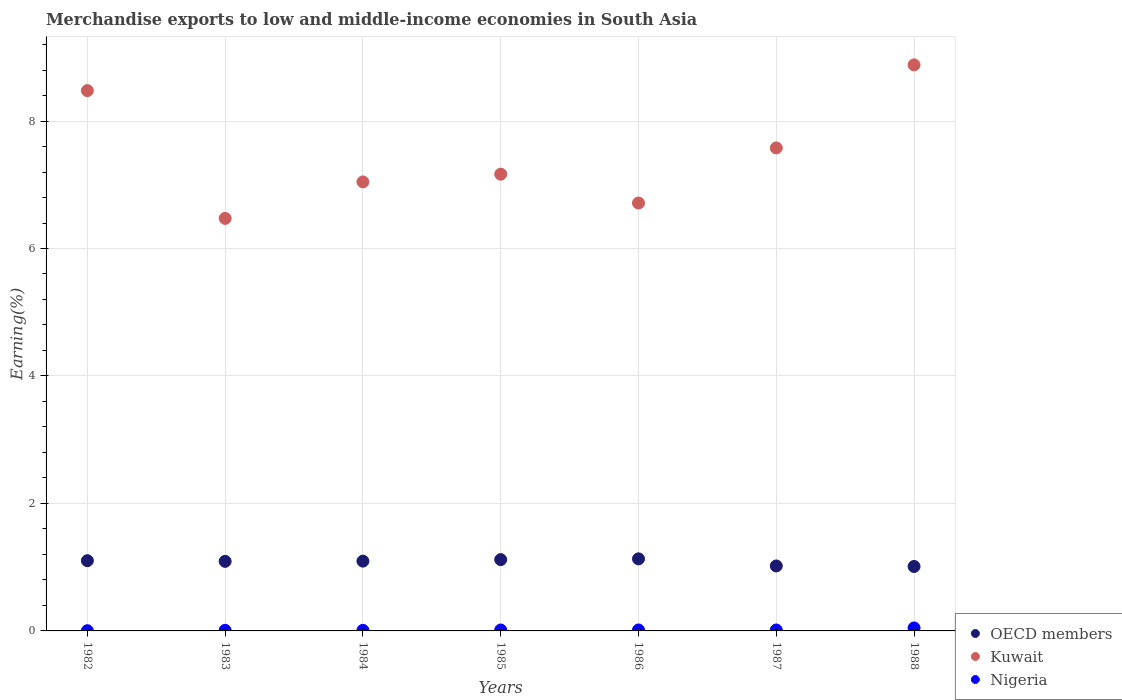How many different coloured dotlines are there?
Ensure brevity in your answer.  3. Is the number of dotlines equal to the number of legend labels?
Offer a terse response. Yes. What is the percentage of amount earned from merchandise exports in OECD members in 1986?
Provide a short and direct response. 1.13. Across all years, what is the maximum percentage of amount earned from merchandise exports in Nigeria?
Your answer should be compact. 0.05. Across all years, what is the minimum percentage of amount earned from merchandise exports in Kuwait?
Ensure brevity in your answer.  6.47. In which year was the percentage of amount earned from merchandise exports in OECD members maximum?
Offer a terse response. 1986. In which year was the percentage of amount earned from merchandise exports in Kuwait minimum?
Provide a short and direct response. 1983. What is the total percentage of amount earned from merchandise exports in OECD members in the graph?
Offer a very short reply. 7.57. What is the difference between the percentage of amount earned from merchandise exports in Kuwait in 1986 and that in 1988?
Give a very brief answer. -2.17. What is the difference between the percentage of amount earned from merchandise exports in OECD members in 1983 and the percentage of amount earned from merchandise exports in Kuwait in 1987?
Ensure brevity in your answer.  -6.49. What is the average percentage of amount earned from merchandise exports in Kuwait per year?
Ensure brevity in your answer.  7.48. In the year 1986, what is the difference between the percentage of amount earned from merchandise exports in OECD members and percentage of amount earned from merchandise exports in Nigeria?
Offer a very short reply. 1.12. What is the ratio of the percentage of amount earned from merchandise exports in OECD members in 1985 to that in 1986?
Make the answer very short. 0.99. Is the difference between the percentage of amount earned from merchandise exports in OECD members in 1983 and 1985 greater than the difference between the percentage of amount earned from merchandise exports in Nigeria in 1983 and 1985?
Give a very brief answer. No. What is the difference between the highest and the second highest percentage of amount earned from merchandise exports in Kuwait?
Offer a terse response. 0.4. What is the difference between the highest and the lowest percentage of amount earned from merchandise exports in Kuwait?
Make the answer very short. 2.41. In how many years, is the percentage of amount earned from merchandise exports in OECD members greater than the average percentage of amount earned from merchandise exports in OECD members taken over all years?
Give a very brief answer. 5. Is it the case that in every year, the sum of the percentage of amount earned from merchandise exports in Kuwait and percentage of amount earned from merchandise exports in Nigeria  is greater than the percentage of amount earned from merchandise exports in OECD members?
Give a very brief answer. Yes. Is the percentage of amount earned from merchandise exports in OECD members strictly less than the percentage of amount earned from merchandise exports in Nigeria over the years?
Make the answer very short. No. Does the graph contain any zero values?
Provide a succinct answer. No. Does the graph contain grids?
Your response must be concise. Yes. Where does the legend appear in the graph?
Offer a very short reply. Bottom right. What is the title of the graph?
Provide a succinct answer. Merchandise exports to low and middle-income economies in South Asia. What is the label or title of the Y-axis?
Offer a terse response. Earning(%). What is the Earning(%) of OECD members in 1982?
Your response must be concise. 1.1. What is the Earning(%) in Kuwait in 1982?
Your answer should be compact. 8.48. What is the Earning(%) of Nigeria in 1982?
Your answer should be very brief. 0. What is the Earning(%) of OECD members in 1983?
Your answer should be very brief. 1.09. What is the Earning(%) of Kuwait in 1983?
Offer a terse response. 6.47. What is the Earning(%) of Nigeria in 1983?
Give a very brief answer. 0.01. What is the Earning(%) of OECD members in 1984?
Your response must be concise. 1.1. What is the Earning(%) of Kuwait in 1984?
Your answer should be very brief. 7.04. What is the Earning(%) in Nigeria in 1984?
Provide a succinct answer. 0.01. What is the Earning(%) of OECD members in 1985?
Keep it short and to the point. 1.12. What is the Earning(%) in Kuwait in 1985?
Your answer should be very brief. 7.17. What is the Earning(%) of Nigeria in 1985?
Your answer should be compact. 0.01. What is the Earning(%) of OECD members in 1986?
Offer a very short reply. 1.13. What is the Earning(%) of Kuwait in 1986?
Ensure brevity in your answer.  6.71. What is the Earning(%) in Nigeria in 1986?
Your answer should be compact. 0.02. What is the Earning(%) of OECD members in 1987?
Your answer should be compact. 1.02. What is the Earning(%) in Kuwait in 1987?
Your answer should be compact. 7.58. What is the Earning(%) in Nigeria in 1987?
Offer a very short reply. 0.02. What is the Earning(%) in OECD members in 1988?
Make the answer very short. 1.01. What is the Earning(%) in Kuwait in 1988?
Give a very brief answer. 8.88. What is the Earning(%) in Nigeria in 1988?
Keep it short and to the point. 0.05. Across all years, what is the maximum Earning(%) in OECD members?
Give a very brief answer. 1.13. Across all years, what is the maximum Earning(%) of Kuwait?
Offer a very short reply. 8.88. Across all years, what is the maximum Earning(%) in Nigeria?
Keep it short and to the point. 0.05. Across all years, what is the minimum Earning(%) of OECD members?
Keep it short and to the point. 1.01. Across all years, what is the minimum Earning(%) in Kuwait?
Your answer should be very brief. 6.47. Across all years, what is the minimum Earning(%) in Nigeria?
Provide a short and direct response. 0. What is the total Earning(%) in OECD members in the graph?
Provide a succinct answer. 7.57. What is the total Earning(%) in Kuwait in the graph?
Offer a terse response. 52.33. What is the total Earning(%) of Nigeria in the graph?
Provide a short and direct response. 0.11. What is the difference between the Earning(%) in OECD members in 1982 and that in 1983?
Provide a short and direct response. 0.01. What is the difference between the Earning(%) of Kuwait in 1982 and that in 1983?
Your answer should be very brief. 2. What is the difference between the Earning(%) of Nigeria in 1982 and that in 1983?
Offer a terse response. -0.01. What is the difference between the Earning(%) of OECD members in 1982 and that in 1984?
Give a very brief answer. 0.01. What is the difference between the Earning(%) of Kuwait in 1982 and that in 1984?
Make the answer very short. 1.43. What is the difference between the Earning(%) of Nigeria in 1982 and that in 1984?
Your response must be concise. -0.01. What is the difference between the Earning(%) of OECD members in 1982 and that in 1985?
Ensure brevity in your answer.  -0.02. What is the difference between the Earning(%) of Kuwait in 1982 and that in 1985?
Ensure brevity in your answer.  1.31. What is the difference between the Earning(%) in Nigeria in 1982 and that in 1985?
Provide a short and direct response. -0.01. What is the difference between the Earning(%) of OECD members in 1982 and that in 1986?
Give a very brief answer. -0.03. What is the difference between the Earning(%) in Kuwait in 1982 and that in 1986?
Your answer should be very brief. 1.76. What is the difference between the Earning(%) of Nigeria in 1982 and that in 1986?
Ensure brevity in your answer.  -0.01. What is the difference between the Earning(%) in OECD members in 1982 and that in 1987?
Offer a terse response. 0.08. What is the difference between the Earning(%) in Kuwait in 1982 and that in 1987?
Keep it short and to the point. 0.9. What is the difference between the Earning(%) in Nigeria in 1982 and that in 1987?
Provide a short and direct response. -0.01. What is the difference between the Earning(%) in OECD members in 1982 and that in 1988?
Offer a terse response. 0.09. What is the difference between the Earning(%) of Kuwait in 1982 and that in 1988?
Your answer should be compact. -0.4. What is the difference between the Earning(%) of Nigeria in 1982 and that in 1988?
Offer a very short reply. -0.04. What is the difference between the Earning(%) in OECD members in 1983 and that in 1984?
Keep it short and to the point. -0. What is the difference between the Earning(%) of Kuwait in 1983 and that in 1984?
Give a very brief answer. -0.57. What is the difference between the Earning(%) in OECD members in 1983 and that in 1985?
Keep it short and to the point. -0.03. What is the difference between the Earning(%) in Kuwait in 1983 and that in 1985?
Ensure brevity in your answer.  -0.69. What is the difference between the Earning(%) in Nigeria in 1983 and that in 1985?
Keep it short and to the point. -0.01. What is the difference between the Earning(%) in OECD members in 1983 and that in 1986?
Ensure brevity in your answer.  -0.04. What is the difference between the Earning(%) of Kuwait in 1983 and that in 1986?
Your answer should be compact. -0.24. What is the difference between the Earning(%) of Nigeria in 1983 and that in 1986?
Your answer should be very brief. -0.01. What is the difference between the Earning(%) in OECD members in 1983 and that in 1987?
Provide a succinct answer. 0.07. What is the difference between the Earning(%) in Kuwait in 1983 and that in 1987?
Offer a very short reply. -1.11. What is the difference between the Earning(%) of Nigeria in 1983 and that in 1987?
Make the answer very short. -0.01. What is the difference between the Earning(%) in OECD members in 1983 and that in 1988?
Ensure brevity in your answer.  0.08. What is the difference between the Earning(%) in Kuwait in 1983 and that in 1988?
Your response must be concise. -2.41. What is the difference between the Earning(%) in Nigeria in 1983 and that in 1988?
Give a very brief answer. -0.04. What is the difference between the Earning(%) of OECD members in 1984 and that in 1985?
Give a very brief answer. -0.02. What is the difference between the Earning(%) in Kuwait in 1984 and that in 1985?
Make the answer very short. -0.12. What is the difference between the Earning(%) in Nigeria in 1984 and that in 1985?
Give a very brief answer. -0.01. What is the difference between the Earning(%) in OECD members in 1984 and that in 1986?
Provide a short and direct response. -0.04. What is the difference between the Earning(%) in Kuwait in 1984 and that in 1986?
Ensure brevity in your answer.  0.33. What is the difference between the Earning(%) of Nigeria in 1984 and that in 1986?
Provide a short and direct response. -0.01. What is the difference between the Earning(%) of OECD members in 1984 and that in 1987?
Keep it short and to the point. 0.08. What is the difference between the Earning(%) in Kuwait in 1984 and that in 1987?
Your response must be concise. -0.53. What is the difference between the Earning(%) of Nigeria in 1984 and that in 1987?
Your response must be concise. -0.01. What is the difference between the Earning(%) in OECD members in 1984 and that in 1988?
Offer a very short reply. 0.08. What is the difference between the Earning(%) in Kuwait in 1984 and that in 1988?
Your response must be concise. -1.84. What is the difference between the Earning(%) in Nigeria in 1984 and that in 1988?
Offer a very short reply. -0.04. What is the difference between the Earning(%) of OECD members in 1985 and that in 1986?
Your response must be concise. -0.01. What is the difference between the Earning(%) in Kuwait in 1985 and that in 1986?
Give a very brief answer. 0.45. What is the difference between the Earning(%) of Nigeria in 1985 and that in 1986?
Give a very brief answer. -0. What is the difference between the Earning(%) in OECD members in 1985 and that in 1987?
Your answer should be compact. 0.1. What is the difference between the Earning(%) of Kuwait in 1985 and that in 1987?
Your answer should be compact. -0.41. What is the difference between the Earning(%) in Nigeria in 1985 and that in 1987?
Your answer should be compact. -0. What is the difference between the Earning(%) in OECD members in 1985 and that in 1988?
Provide a succinct answer. 0.11. What is the difference between the Earning(%) of Kuwait in 1985 and that in 1988?
Your answer should be compact. -1.71. What is the difference between the Earning(%) of Nigeria in 1985 and that in 1988?
Provide a succinct answer. -0.03. What is the difference between the Earning(%) of OECD members in 1986 and that in 1987?
Your answer should be very brief. 0.11. What is the difference between the Earning(%) in Kuwait in 1986 and that in 1987?
Ensure brevity in your answer.  -0.87. What is the difference between the Earning(%) in Nigeria in 1986 and that in 1987?
Give a very brief answer. -0. What is the difference between the Earning(%) of OECD members in 1986 and that in 1988?
Provide a short and direct response. 0.12. What is the difference between the Earning(%) in Kuwait in 1986 and that in 1988?
Your response must be concise. -2.17. What is the difference between the Earning(%) of Nigeria in 1986 and that in 1988?
Your answer should be very brief. -0.03. What is the difference between the Earning(%) in OECD members in 1987 and that in 1988?
Offer a very short reply. 0.01. What is the difference between the Earning(%) in Kuwait in 1987 and that in 1988?
Offer a very short reply. -1.3. What is the difference between the Earning(%) in Nigeria in 1987 and that in 1988?
Offer a terse response. -0.03. What is the difference between the Earning(%) of OECD members in 1982 and the Earning(%) of Kuwait in 1983?
Provide a succinct answer. -5.37. What is the difference between the Earning(%) of OECD members in 1982 and the Earning(%) of Nigeria in 1983?
Make the answer very short. 1.09. What is the difference between the Earning(%) in Kuwait in 1982 and the Earning(%) in Nigeria in 1983?
Offer a very short reply. 8.47. What is the difference between the Earning(%) in OECD members in 1982 and the Earning(%) in Kuwait in 1984?
Offer a terse response. -5.94. What is the difference between the Earning(%) in OECD members in 1982 and the Earning(%) in Nigeria in 1984?
Ensure brevity in your answer.  1.09. What is the difference between the Earning(%) in Kuwait in 1982 and the Earning(%) in Nigeria in 1984?
Your response must be concise. 8.47. What is the difference between the Earning(%) in OECD members in 1982 and the Earning(%) in Kuwait in 1985?
Give a very brief answer. -6.06. What is the difference between the Earning(%) in OECD members in 1982 and the Earning(%) in Nigeria in 1985?
Your answer should be very brief. 1.09. What is the difference between the Earning(%) in Kuwait in 1982 and the Earning(%) in Nigeria in 1985?
Ensure brevity in your answer.  8.46. What is the difference between the Earning(%) in OECD members in 1982 and the Earning(%) in Kuwait in 1986?
Offer a terse response. -5.61. What is the difference between the Earning(%) of OECD members in 1982 and the Earning(%) of Nigeria in 1986?
Make the answer very short. 1.09. What is the difference between the Earning(%) in Kuwait in 1982 and the Earning(%) in Nigeria in 1986?
Ensure brevity in your answer.  8.46. What is the difference between the Earning(%) in OECD members in 1982 and the Earning(%) in Kuwait in 1987?
Your answer should be very brief. -6.48. What is the difference between the Earning(%) of OECD members in 1982 and the Earning(%) of Nigeria in 1987?
Your answer should be compact. 1.09. What is the difference between the Earning(%) of Kuwait in 1982 and the Earning(%) of Nigeria in 1987?
Ensure brevity in your answer.  8.46. What is the difference between the Earning(%) in OECD members in 1982 and the Earning(%) in Kuwait in 1988?
Your answer should be very brief. -7.78. What is the difference between the Earning(%) of OECD members in 1982 and the Earning(%) of Nigeria in 1988?
Make the answer very short. 1.06. What is the difference between the Earning(%) of Kuwait in 1982 and the Earning(%) of Nigeria in 1988?
Offer a terse response. 8.43. What is the difference between the Earning(%) in OECD members in 1983 and the Earning(%) in Kuwait in 1984?
Your answer should be very brief. -5.95. What is the difference between the Earning(%) of OECD members in 1983 and the Earning(%) of Nigeria in 1984?
Give a very brief answer. 1.08. What is the difference between the Earning(%) in Kuwait in 1983 and the Earning(%) in Nigeria in 1984?
Provide a short and direct response. 6.46. What is the difference between the Earning(%) of OECD members in 1983 and the Earning(%) of Kuwait in 1985?
Offer a terse response. -6.07. What is the difference between the Earning(%) in Kuwait in 1983 and the Earning(%) in Nigeria in 1985?
Offer a very short reply. 6.46. What is the difference between the Earning(%) in OECD members in 1983 and the Earning(%) in Kuwait in 1986?
Offer a very short reply. -5.62. What is the difference between the Earning(%) of OECD members in 1983 and the Earning(%) of Nigeria in 1986?
Provide a short and direct response. 1.08. What is the difference between the Earning(%) of Kuwait in 1983 and the Earning(%) of Nigeria in 1986?
Make the answer very short. 6.46. What is the difference between the Earning(%) of OECD members in 1983 and the Earning(%) of Kuwait in 1987?
Your answer should be compact. -6.49. What is the difference between the Earning(%) in OECD members in 1983 and the Earning(%) in Nigeria in 1987?
Keep it short and to the point. 1.08. What is the difference between the Earning(%) of Kuwait in 1983 and the Earning(%) of Nigeria in 1987?
Provide a short and direct response. 6.46. What is the difference between the Earning(%) of OECD members in 1983 and the Earning(%) of Kuwait in 1988?
Your answer should be compact. -7.79. What is the difference between the Earning(%) in OECD members in 1983 and the Earning(%) in Nigeria in 1988?
Provide a short and direct response. 1.04. What is the difference between the Earning(%) of Kuwait in 1983 and the Earning(%) of Nigeria in 1988?
Provide a succinct answer. 6.43. What is the difference between the Earning(%) of OECD members in 1984 and the Earning(%) of Kuwait in 1985?
Your answer should be compact. -6.07. What is the difference between the Earning(%) in OECD members in 1984 and the Earning(%) in Nigeria in 1985?
Your response must be concise. 1.08. What is the difference between the Earning(%) of Kuwait in 1984 and the Earning(%) of Nigeria in 1985?
Ensure brevity in your answer.  7.03. What is the difference between the Earning(%) in OECD members in 1984 and the Earning(%) in Kuwait in 1986?
Your response must be concise. -5.62. What is the difference between the Earning(%) of OECD members in 1984 and the Earning(%) of Nigeria in 1986?
Keep it short and to the point. 1.08. What is the difference between the Earning(%) of Kuwait in 1984 and the Earning(%) of Nigeria in 1986?
Your answer should be compact. 7.03. What is the difference between the Earning(%) in OECD members in 1984 and the Earning(%) in Kuwait in 1987?
Keep it short and to the point. -6.48. What is the difference between the Earning(%) in OECD members in 1984 and the Earning(%) in Nigeria in 1987?
Your answer should be compact. 1.08. What is the difference between the Earning(%) in Kuwait in 1984 and the Earning(%) in Nigeria in 1987?
Offer a very short reply. 7.03. What is the difference between the Earning(%) in OECD members in 1984 and the Earning(%) in Kuwait in 1988?
Make the answer very short. -7.79. What is the difference between the Earning(%) of OECD members in 1984 and the Earning(%) of Nigeria in 1988?
Offer a very short reply. 1.05. What is the difference between the Earning(%) of Kuwait in 1984 and the Earning(%) of Nigeria in 1988?
Provide a succinct answer. 7. What is the difference between the Earning(%) in OECD members in 1985 and the Earning(%) in Kuwait in 1986?
Offer a terse response. -5.59. What is the difference between the Earning(%) in OECD members in 1985 and the Earning(%) in Nigeria in 1986?
Give a very brief answer. 1.1. What is the difference between the Earning(%) of Kuwait in 1985 and the Earning(%) of Nigeria in 1986?
Offer a terse response. 7.15. What is the difference between the Earning(%) in OECD members in 1985 and the Earning(%) in Kuwait in 1987?
Your response must be concise. -6.46. What is the difference between the Earning(%) in OECD members in 1985 and the Earning(%) in Nigeria in 1987?
Your response must be concise. 1.1. What is the difference between the Earning(%) of Kuwait in 1985 and the Earning(%) of Nigeria in 1987?
Offer a very short reply. 7.15. What is the difference between the Earning(%) of OECD members in 1985 and the Earning(%) of Kuwait in 1988?
Offer a terse response. -7.76. What is the difference between the Earning(%) in OECD members in 1985 and the Earning(%) in Nigeria in 1988?
Keep it short and to the point. 1.07. What is the difference between the Earning(%) of Kuwait in 1985 and the Earning(%) of Nigeria in 1988?
Provide a succinct answer. 7.12. What is the difference between the Earning(%) of OECD members in 1986 and the Earning(%) of Kuwait in 1987?
Keep it short and to the point. -6.45. What is the difference between the Earning(%) in OECD members in 1986 and the Earning(%) in Nigeria in 1987?
Ensure brevity in your answer.  1.12. What is the difference between the Earning(%) in Kuwait in 1986 and the Earning(%) in Nigeria in 1987?
Offer a very short reply. 6.7. What is the difference between the Earning(%) in OECD members in 1986 and the Earning(%) in Kuwait in 1988?
Provide a succinct answer. -7.75. What is the difference between the Earning(%) of OECD members in 1986 and the Earning(%) of Nigeria in 1988?
Your answer should be very brief. 1.08. What is the difference between the Earning(%) in Kuwait in 1986 and the Earning(%) in Nigeria in 1988?
Keep it short and to the point. 6.67. What is the difference between the Earning(%) of OECD members in 1987 and the Earning(%) of Kuwait in 1988?
Provide a succinct answer. -7.86. What is the difference between the Earning(%) of OECD members in 1987 and the Earning(%) of Nigeria in 1988?
Keep it short and to the point. 0.97. What is the difference between the Earning(%) of Kuwait in 1987 and the Earning(%) of Nigeria in 1988?
Your answer should be compact. 7.53. What is the average Earning(%) in OECD members per year?
Provide a succinct answer. 1.08. What is the average Earning(%) of Kuwait per year?
Make the answer very short. 7.48. What is the average Earning(%) in Nigeria per year?
Your answer should be very brief. 0.02. In the year 1982, what is the difference between the Earning(%) of OECD members and Earning(%) of Kuwait?
Keep it short and to the point. -7.38. In the year 1982, what is the difference between the Earning(%) of OECD members and Earning(%) of Nigeria?
Ensure brevity in your answer.  1.1. In the year 1982, what is the difference between the Earning(%) of Kuwait and Earning(%) of Nigeria?
Offer a terse response. 8.47. In the year 1983, what is the difference between the Earning(%) of OECD members and Earning(%) of Kuwait?
Make the answer very short. -5.38. In the year 1983, what is the difference between the Earning(%) of OECD members and Earning(%) of Nigeria?
Provide a succinct answer. 1.08. In the year 1983, what is the difference between the Earning(%) in Kuwait and Earning(%) in Nigeria?
Your answer should be very brief. 6.46. In the year 1984, what is the difference between the Earning(%) of OECD members and Earning(%) of Kuwait?
Provide a succinct answer. -5.95. In the year 1984, what is the difference between the Earning(%) in OECD members and Earning(%) in Nigeria?
Give a very brief answer. 1.09. In the year 1984, what is the difference between the Earning(%) in Kuwait and Earning(%) in Nigeria?
Provide a short and direct response. 7.04. In the year 1985, what is the difference between the Earning(%) of OECD members and Earning(%) of Kuwait?
Offer a very short reply. -6.05. In the year 1985, what is the difference between the Earning(%) in OECD members and Earning(%) in Nigeria?
Provide a succinct answer. 1.1. In the year 1985, what is the difference between the Earning(%) of Kuwait and Earning(%) of Nigeria?
Make the answer very short. 7.15. In the year 1986, what is the difference between the Earning(%) in OECD members and Earning(%) in Kuwait?
Your answer should be very brief. -5.58. In the year 1986, what is the difference between the Earning(%) in OECD members and Earning(%) in Nigeria?
Make the answer very short. 1.12. In the year 1986, what is the difference between the Earning(%) of Kuwait and Earning(%) of Nigeria?
Make the answer very short. 6.7. In the year 1987, what is the difference between the Earning(%) of OECD members and Earning(%) of Kuwait?
Your answer should be compact. -6.56. In the year 1987, what is the difference between the Earning(%) of Kuwait and Earning(%) of Nigeria?
Your answer should be very brief. 7.56. In the year 1988, what is the difference between the Earning(%) in OECD members and Earning(%) in Kuwait?
Offer a very short reply. -7.87. In the year 1988, what is the difference between the Earning(%) of OECD members and Earning(%) of Nigeria?
Provide a short and direct response. 0.96. In the year 1988, what is the difference between the Earning(%) in Kuwait and Earning(%) in Nigeria?
Offer a very short reply. 8.83. What is the ratio of the Earning(%) in OECD members in 1982 to that in 1983?
Give a very brief answer. 1.01. What is the ratio of the Earning(%) in Kuwait in 1982 to that in 1983?
Provide a succinct answer. 1.31. What is the ratio of the Earning(%) of Nigeria in 1982 to that in 1983?
Your response must be concise. 0.38. What is the ratio of the Earning(%) of OECD members in 1982 to that in 1984?
Keep it short and to the point. 1.01. What is the ratio of the Earning(%) in Kuwait in 1982 to that in 1984?
Give a very brief answer. 1.2. What is the ratio of the Earning(%) in Nigeria in 1982 to that in 1984?
Give a very brief answer. 0.38. What is the ratio of the Earning(%) in OECD members in 1982 to that in 1985?
Offer a terse response. 0.98. What is the ratio of the Earning(%) of Kuwait in 1982 to that in 1985?
Your response must be concise. 1.18. What is the ratio of the Earning(%) of Nigeria in 1982 to that in 1985?
Your response must be concise. 0.24. What is the ratio of the Earning(%) in OECD members in 1982 to that in 1986?
Ensure brevity in your answer.  0.97. What is the ratio of the Earning(%) in Kuwait in 1982 to that in 1986?
Provide a short and direct response. 1.26. What is the ratio of the Earning(%) of Nigeria in 1982 to that in 1986?
Give a very brief answer. 0.23. What is the ratio of the Earning(%) of OECD members in 1982 to that in 1987?
Your answer should be compact. 1.08. What is the ratio of the Earning(%) of Kuwait in 1982 to that in 1987?
Your response must be concise. 1.12. What is the ratio of the Earning(%) in Nigeria in 1982 to that in 1987?
Keep it short and to the point. 0.23. What is the ratio of the Earning(%) in OECD members in 1982 to that in 1988?
Ensure brevity in your answer.  1.09. What is the ratio of the Earning(%) in Kuwait in 1982 to that in 1988?
Offer a very short reply. 0.95. What is the ratio of the Earning(%) in Nigeria in 1982 to that in 1988?
Ensure brevity in your answer.  0.08. What is the ratio of the Earning(%) in Kuwait in 1983 to that in 1984?
Your response must be concise. 0.92. What is the ratio of the Earning(%) in Nigeria in 1983 to that in 1984?
Your answer should be compact. 1.02. What is the ratio of the Earning(%) of OECD members in 1983 to that in 1985?
Make the answer very short. 0.98. What is the ratio of the Earning(%) in Kuwait in 1983 to that in 1985?
Provide a short and direct response. 0.9. What is the ratio of the Earning(%) in Nigeria in 1983 to that in 1985?
Your response must be concise. 0.64. What is the ratio of the Earning(%) in OECD members in 1983 to that in 1986?
Offer a terse response. 0.97. What is the ratio of the Earning(%) in Kuwait in 1983 to that in 1986?
Provide a short and direct response. 0.96. What is the ratio of the Earning(%) in Nigeria in 1983 to that in 1986?
Provide a short and direct response. 0.62. What is the ratio of the Earning(%) in OECD members in 1983 to that in 1987?
Your answer should be compact. 1.07. What is the ratio of the Earning(%) in Kuwait in 1983 to that in 1987?
Offer a very short reply. 0.85. What is the ratio of the Earning(%) of Nigeria in 1983 to that in 1987?
Your response must be concise. 0.62. What is the ratio of the Earning(%) in OECD members in 1983 to that in 1988?
Make the answer very short. 1.08. What is the ratio of the Earning(%) in Kuwait in 1983 to that in 1988?
Ensure brevity in your answer.  0.73. What is the ratio of the Earning(%) in Nigeria in 1983 to that in 1988?
Offer a very short reply. 0.2. What is the ratio of the Earning(%) in OECD members in 1984 to that in 1985?
Ensure brevity in your answer.  0.98. What is the ratio of the Earning(%) of Kuwait in 1984 to that in 1985?
Provide a succinct answer. 0.98. What is the ratio of the Earning(%) of Nigeria in 1984 to that in 1985?
Provide a short and direct response. 0.63. What is the ratio of the Earning(%) of OECD members in 1984 to that in 1986?
Keep it short and to the point. 0.97. What is the ratio of the Earning(%) of Kuwait in 1984 to that in 1986?
Keep it short and to the point. 1.05. What is the ratio of the Earning(%) of Nigeria in 1984 to that in 1986?
Your response must be concise. 0.61. What is the ratio of the Earning(%) of OECD members in 1984 to that in 1987?
Ensure brevity in your answer.  1.07. What is the ratio of the Earning(%) in Kuwait in 1984 to that in 1987?
Make the answer very short. 0.93. What is the ratio of the Earning(%) in Nigeria in 1984 to that in 1987?
Provide a succinct answer. 0.61. What is the ratio of the Earning(%) in OECD members in 1984 to that in 1988?
Ensure brevity in your answer.  1.08. What is the ratio of the Earning(%) in Kuwait in 1984 to that in 1988?
Your answer should be very brief. 0.79. What is the ratio of the Earning(%) of Nigeria in 1984 to that in 1988?
Ensure brevity in your answer.  0.2. What is the ratio of the Earning(%) of OECD members in 1985 to that in 1986?
Offer a terse response. 0.99. What is the ratio of the Earning(%) in Kuwait in 1985 to that in 1986?
Give a very brief answer. 1.07. What is the ratio of the Earning(%) in Nigeria in 1985 to that in 1986?
Provide a succinct answer. 0.97. What is the ratio of the Earning(%) of OECD members in 1985 to that in 1987?
Ensure brevity in your answer.  1.1. What is the ratio of the Earning(%) of Kuwait in 1985 to that in 1987?
Provide a short and direct response. 0.95. What is the ratio of the Earning(%) of Nigeria in 1985 to that in 1987?
Your answer should be compact. 0.97. What is the ratio of the Earning(%) of OECD members in 1985 to that in 1988?
Give a very brief answer. 1.11. What is the ratio of the Earning(%) of Kuwait in 1985 to that in 1988?
Provide a succinct answer. 0.81. What is the ratio of the Earning(%) of Nigeria in 1985 to that in 1988?
Offer a very short reply. 0.31. What is the ratio of the Earning(%) in OECD members in 1986 to that in 1987?
Make the answer very short. 1.11. What is the ratio of the Earning(%) in Kuwait in 1986 to that in 1987?
Ensure brevity in your answer.  0.89. What is the ratio of the Earning(%) in OECD members in 1986 to that in 1988?
Offer a terse response. 1.12. What is the ratio of the Earning(%) in Kuwait in 1986 to that in 1988?
Offer a terse response. 0.76. What is the ratio of the Earning(%) of Nigeria in 1986 to that in 1988?
Provide a short and direct response. 0.32. What is the ratio of the Earning(%) of OECD members in 1987 to that in 1988?
Your response must be concise. 1.01. What is the ratio of the Earning(%) of Kuwait in 1987 to that in 1988?
Offer a very short reply. 0.85. What is the ratio of the Earning(%) in Nigeria in 1987 to that in 1988?
Your answer should be compact. 0.32. What is the difference between the highest and the second highest Earning(%) in OECD members?
Keep it short and to the point. 0.01. What is the difference between the highest and the second highest Earning(%) in Kuwait?
Your answer should be very brief. 0.4. What is the difference between the highest and the second highest Earning(%) of Nigeria?
Provide a succinct answer. 0.03. What is the difference between the highest and the lowest Earning(%) in OECD members?
Your answer should be compact. 0.12. What is the difference between the highest and the lowest Earning(%) in Kuwait?
Your answer should be very brief. 2.41. What is the difference between the highest and the lowest Earning(%) of Nigeria?
Make the answer very short. 0.04. 